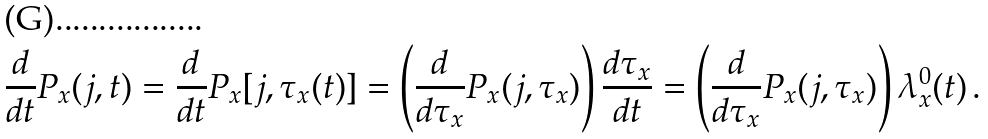Convert formula to latex. <formula><loc_0><loc_0><loc_500><loc_500>\frac { d } { d t } P _ { x } ( j , t ) = \frac { d } { d t } P _ { x } [ j , \tau _ { x } ( t ) ] = \left ( \frac { d } { d \tau _ { x } } P _ { x } ( j , \tau _ { x } ) \right ) \frac { d \tau _ { x } } { d t } = \left ( \frac { d } { d \tau _ { x } } P _ { x } ( j , \tau _ { x } ) \right ) \lambda _ { x } ^ { 0 } ( t ) \, .</formula> 